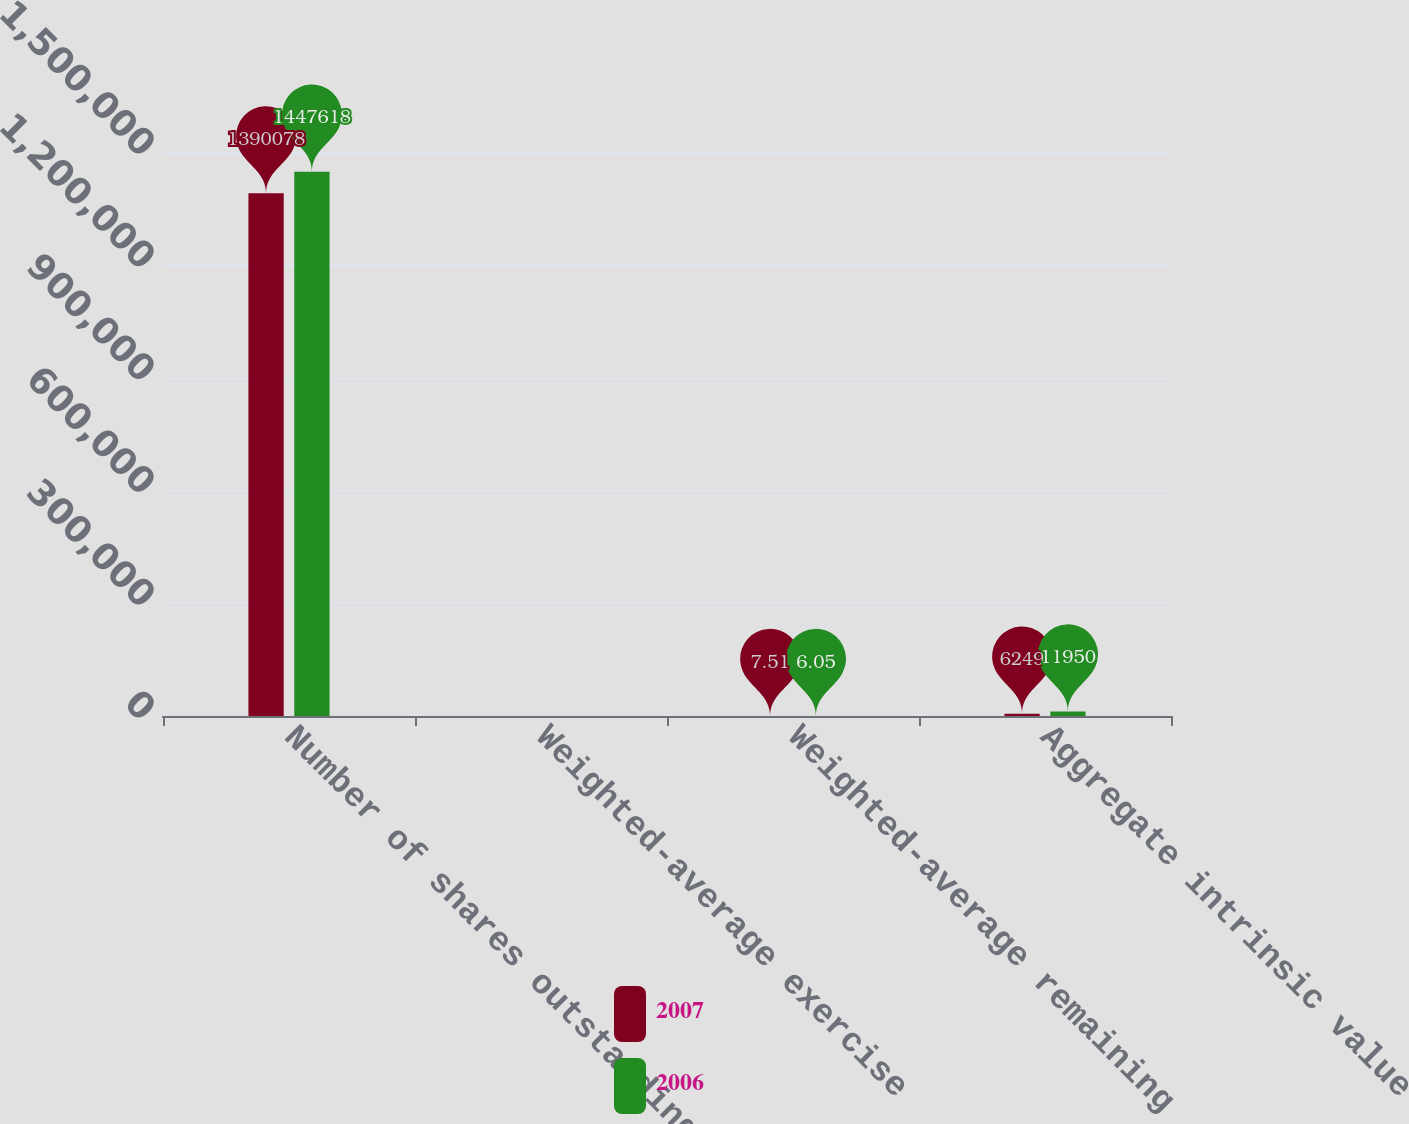Convert chart. <chart><loc_0><loc_0><loc_500><loc_500><stacked_bar_chart><ecel><fcel>Number of shares outstanding<fcel>Weighted-average exercise<fcel>Weighted-average remaining<fcel>Aggregate intrinsic value<nl><fcel>2007<fcel>1.39008e+06<fcel>59.64<fcel>7.51<fcel>6249<nl><fcel>2006<fcel>1.44762e+06<fcel>55.5<fcel>6.05<fcel>11950<nl></chart> 